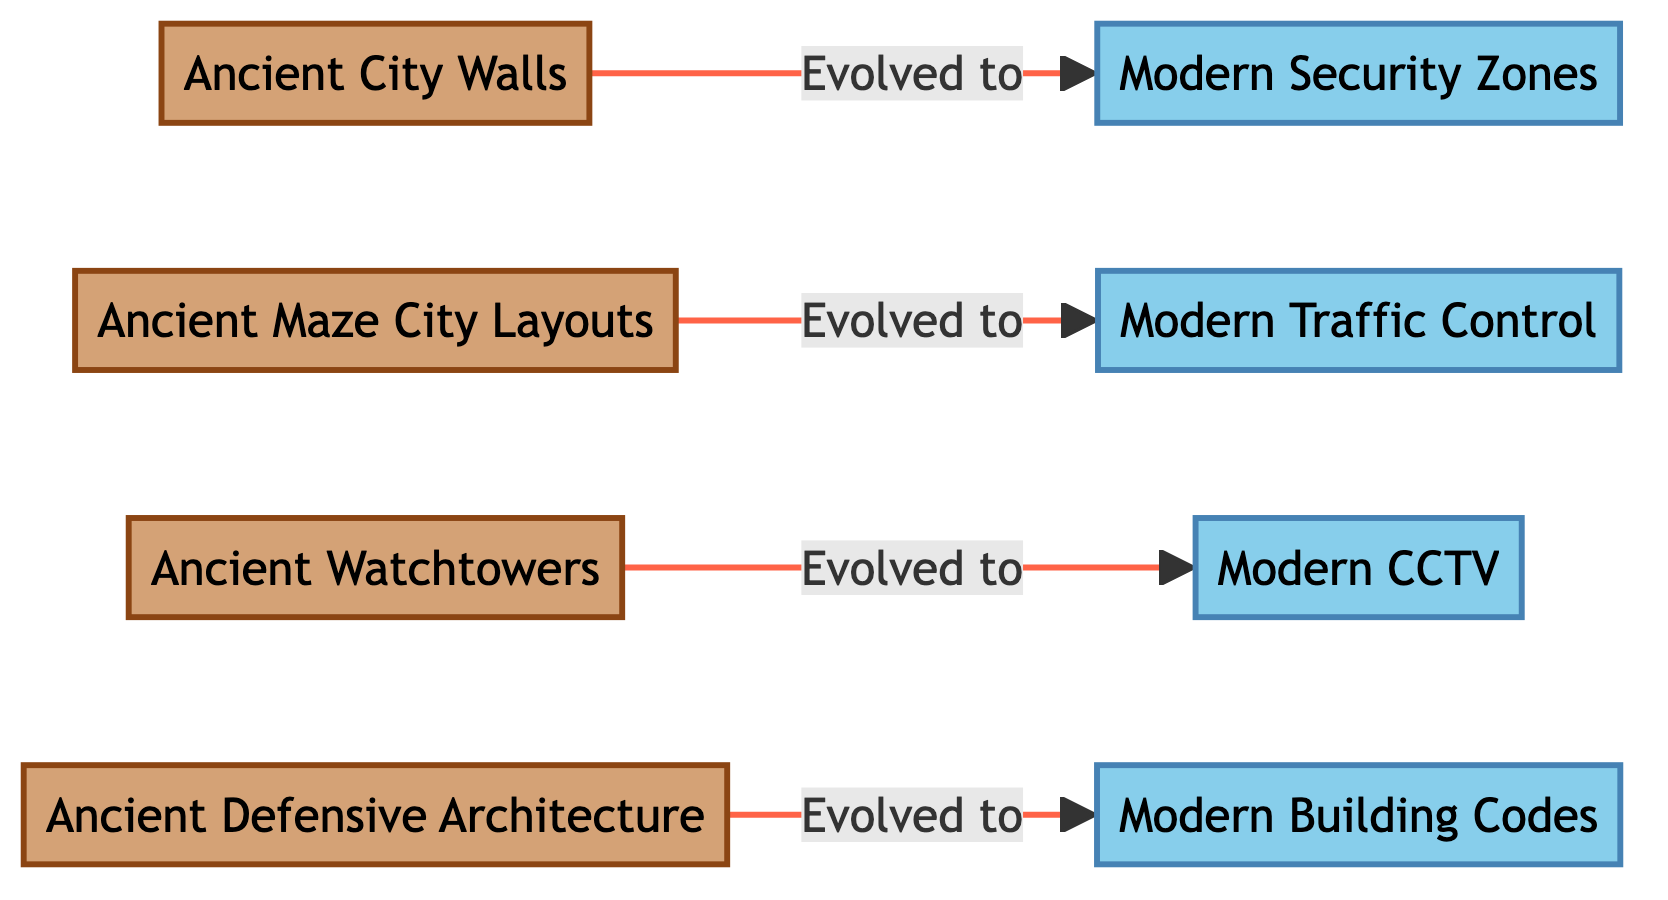What are the two categories of defensive strategies depicted in the diagram? The diagram explicitly categorizes defensive strategies into two groups: Ancient and Modern. Each category is represented distinctly, with ancient strategies on the left and modern strategies on the right.
Answer: Ancient and Modern How many ancient defensive strategies are shown in the diagram? Counting the nodes listed within the ancient category, we find four strategies: Ancient City Walls, Ancient Maze City Layouts, Ancient Watchtowers, and Ancient Defensive Architecture, totaling four strategies.
Answer: 4 What is the connection between Ancient City Walls and Modern Security Zones? The diagram shows that Ancient City Walls evolved to become Modern Security Zones, indicating a direct developmental relationship from the ancient to the modern strategy.
Answer: Evolved to Which two modern defensive strategies are linked to traffic control? The diagram illustrates that Ancient Maze City Layouts evolved into Modern Traffic Control, indicating the connection of these two specific strategies in the modern category.
Answer: Ancient Maze City Layouts and Modern Traffic Control What is one ancient defensive architecture that has evolved into a modern security solution? The diagram indicates that Ancient Defensive Architecture has evolved into Modern Building Codes, showcasing a transformation in defensive strategies.
Answer: Ancient Defensive Architecture How many edges are connecting the ancient defensive strategies to their modern counterparts? There are four established connections or edges in the diagram, each linking an ancient strategy to its respective modern evolution, representing the flow of development in defensive strategies.
Answer: 4 What modern security feature has replaced the concept of Ancient Watchtowers? According to the diagram, Ancient Watchtowers have evolved into Modern CCTV, representing the transition from physical watchpoints to modern surveillance systems.
Answer: Modern CCTV Which ancient defensive feature connects to modern building codes? The diagram clearly shows that Ancient Defensive Architecture has evolved and is directly linked to Modern Building Codes, representing a significant evolutionary change in urban defense strategies.
Answer: Ancient Defensive Architecture What visual styling is used to distinguish between ancient and modern defensive strategies? The diagram employs different color schemes to differentiate the two categories: a warm color for ancient strategies (tan) and a cool color for modern strategies (light blue), aiding in visual comprehension.
Answer: Color schemes 